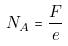<formula> <loc_0><loc_0><loc_500><loc_500>N _ { A } = \frac { F } { e }</formula> 